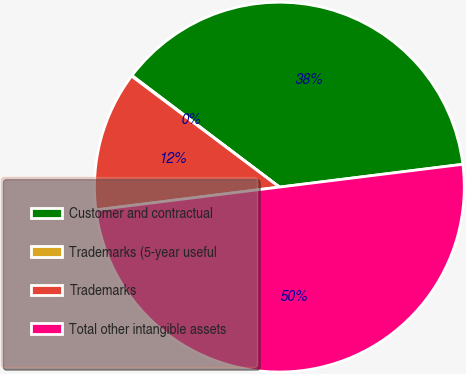Convert chart to OTSL. <chart><loc_0><loc_0><loc_500><loc_500><pie_chart><fcel>Customer and contractual<fcel>Trademarks (5-year useful<fcel>Trademarks<fcel>Total other intangible assets<nl><fcel>37.72%<fcel>0.06%<fcel>12.22%<fcel>50.0%<nl></chart> 